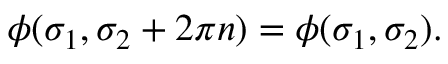<formula> <loc_0><loc_0><loc_500><loc_500>\phi ( \sigma _ { 1 } , \sigma _ { 2 } + 2 \pi n ) = \phi ( \sigma _ { 1 } , \sigma _ { 2 } ) .</formula> 